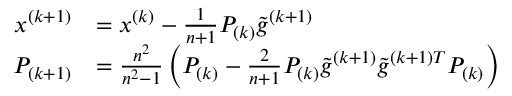Convert formula to latex. <formula><loc_0><loc_0><loc_500><loc_500>{ \begin{array} { r l } { x ^ { ( k + 1 ) } } & { = x ^ { ( k ) } - { \frac { 1 } { n + 1 } } P _ { ( k ) } { \tilde { g } } ^ { ( k + 1 ) } } \\ { P _ { ( k + 1 ) } } & { = { \frac { n ^ { 2 } } { n ^ { 2 } - 1 } } \left ( P _ { ( k ) } - { \frac { 2 } { n + 1 } } P _ { ( k ) } { \tilde { g } } ^ { ( k + 1 ) } { \tilde { g } } ^ { ( k + 1 ) T } P _ { ( k ) } \right ) } \end{array} }</formula> 